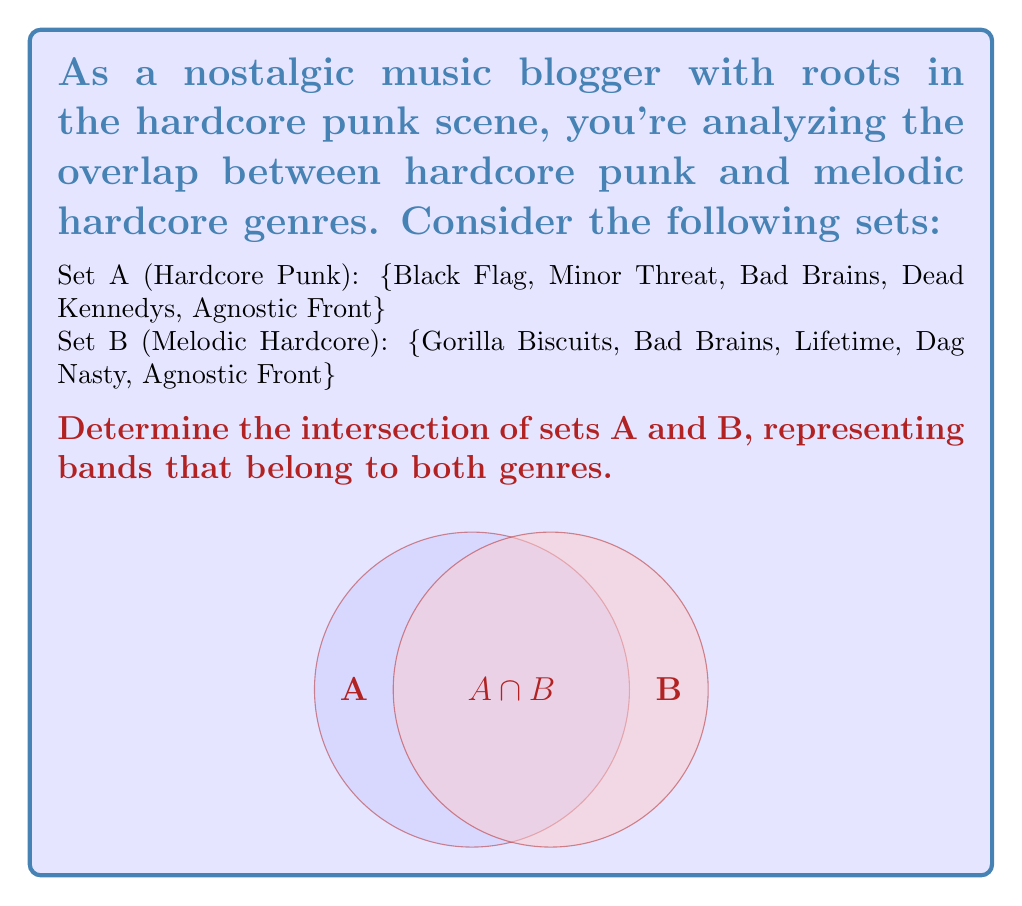Solve this math problem. To find the intersection of sets A and B, we need to identify the elements that are present in both sets. Let's follow these steps:

1. List out the elements of both sets:
   Set A: {Black Flag, Minor Threat, Bad Brains, Dead Kennedys, Agnostic Front}
   Set B: {Gorilla Biscuits, Bad Brains, Lifetime, Dag Nasty, Agnostic Front}

2. Identify the common elements:
   - Bad Brains appears in both sets
   - Agnostic Front appears in both sets

3. The intersection of A and B, denoted as $A \cap B$, contains these common elements.

4. Mathematically, we can express this as:
   $$A \cap B = \{x : x \in A \text{ and } x \in B\}$$

5. In this case, $A \cap B = \{\text{Bad Brains, Agnostic Front}\}$

This intersection represents bands that are considered part of both the hardcore punk and melodic hardcore genres, showcasing the evolution and overlap within the punk scene.
Answer: $A \cap B = \{\text{Bad Brains, Agnostic Front}\}$ 